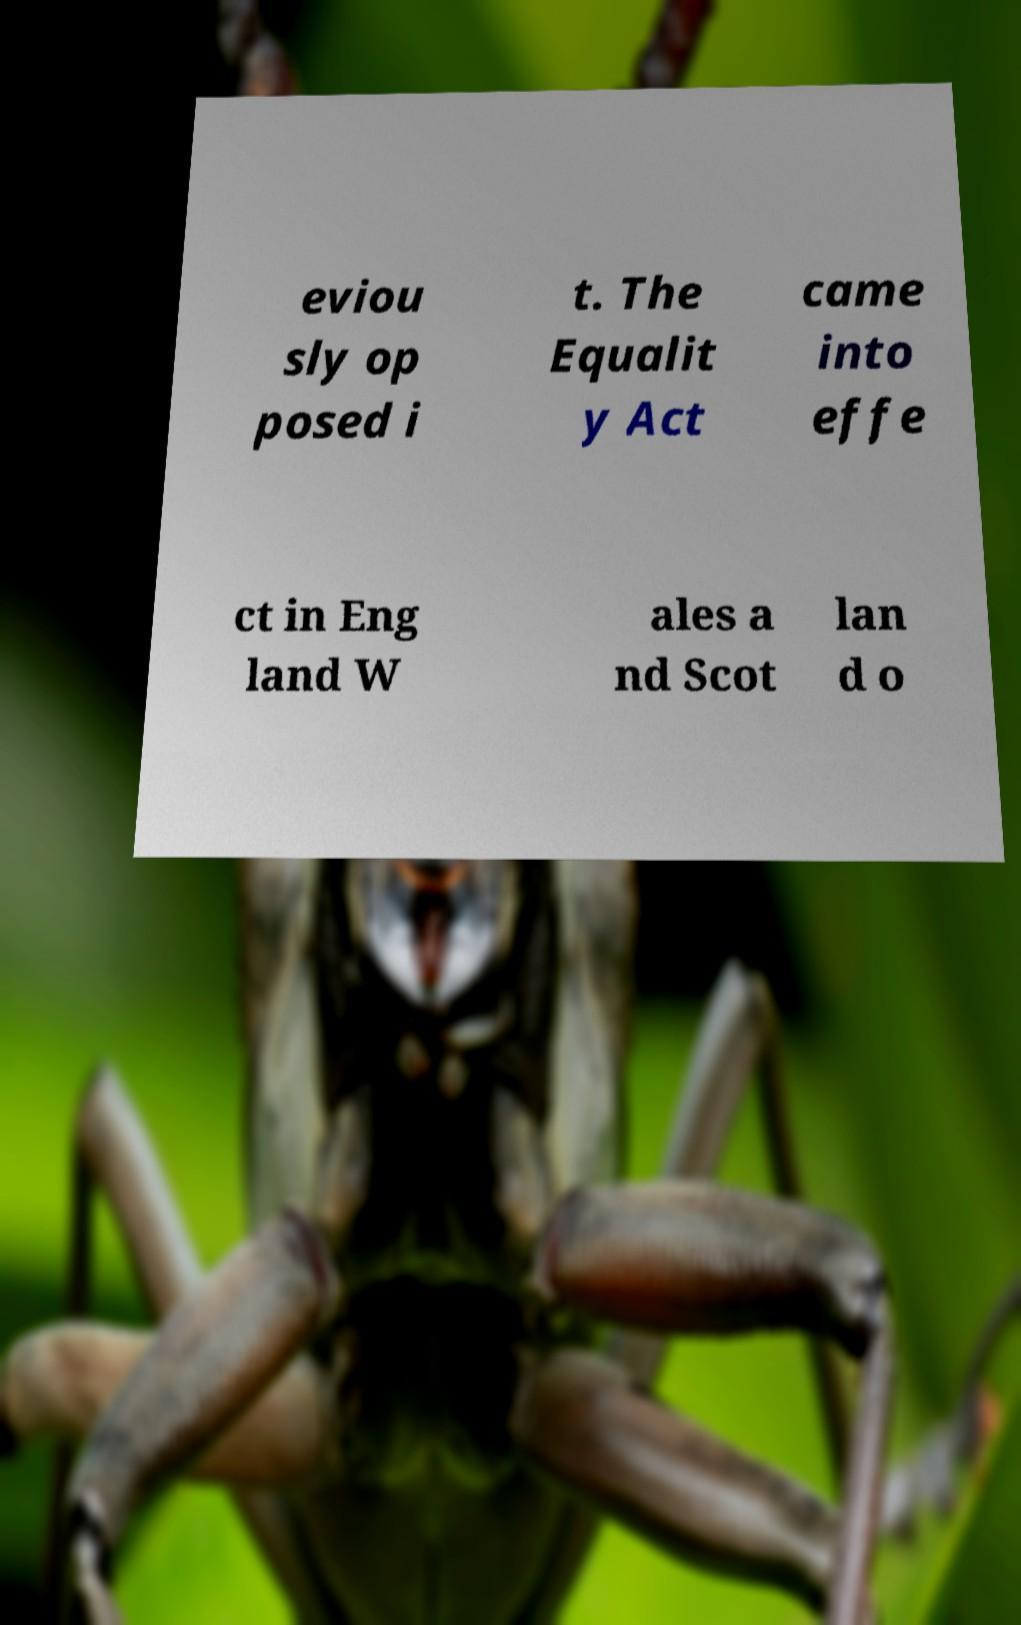Please read and relay the text visible in this image. What does it say? eviou sly op posed i t. The Equalit y Act came into effe ct in Eng land W ales a nd Scot lan d o 